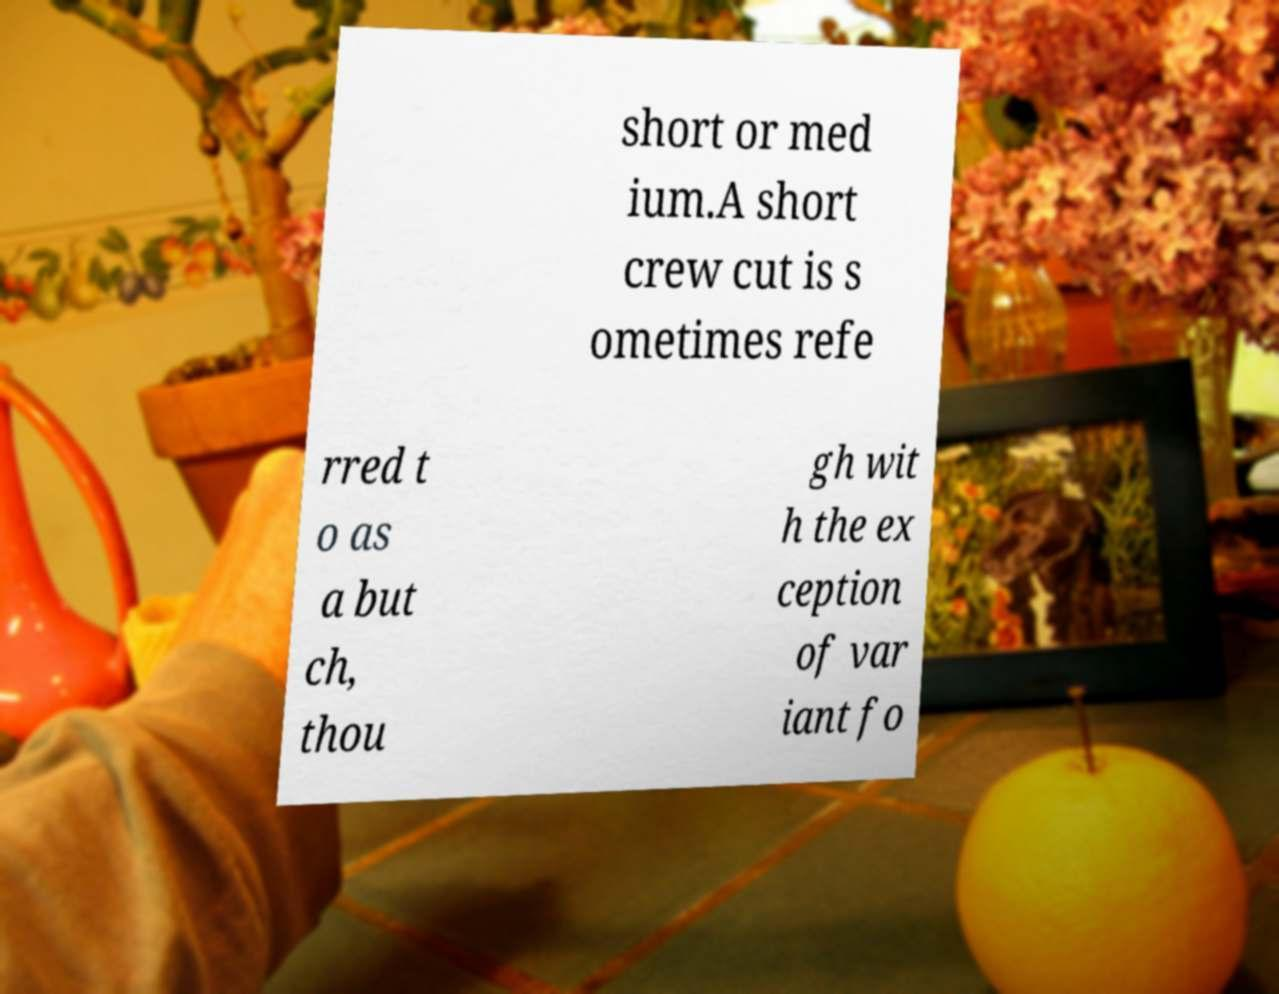Please identify and transcribe the text found in this image. short or med ium.A short crew cut is s ometimes refe rred t o as a but ch, thou gh wit h the ex ception of var iant fo 